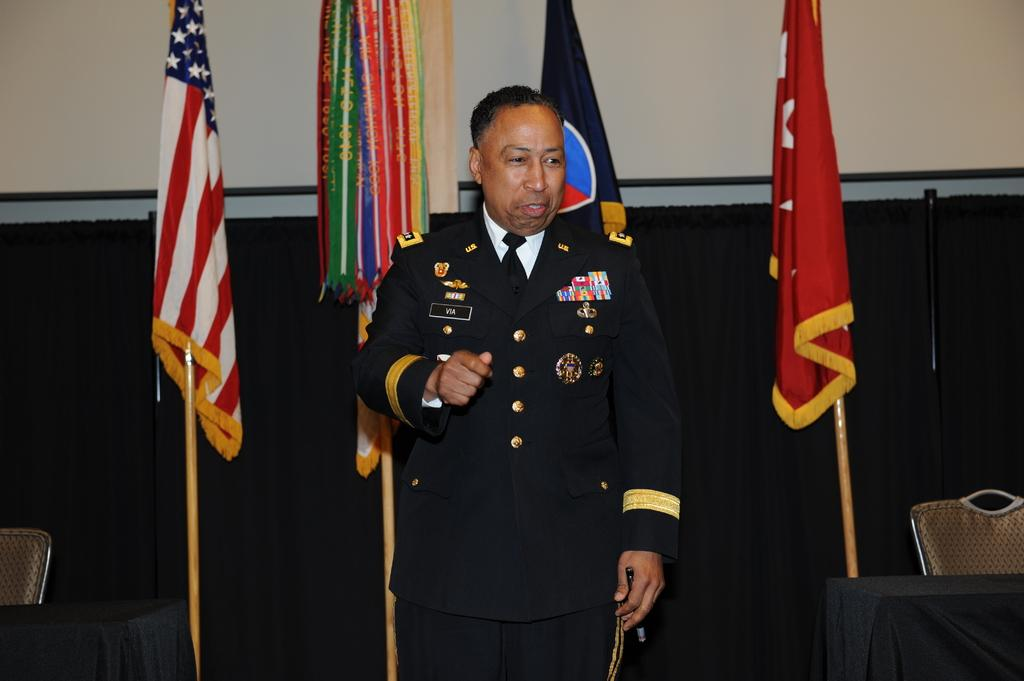What is the man in the image doing? The man is standing in the image. What is the man wearing? The man is wearing a uniform. What can be seen in the background of the image? There are flags and a wall in the background of the image, along with other objects. What type of smoke can be seen coming from the train in the image? There is no train present in the image, so there is no smoke to observe. 